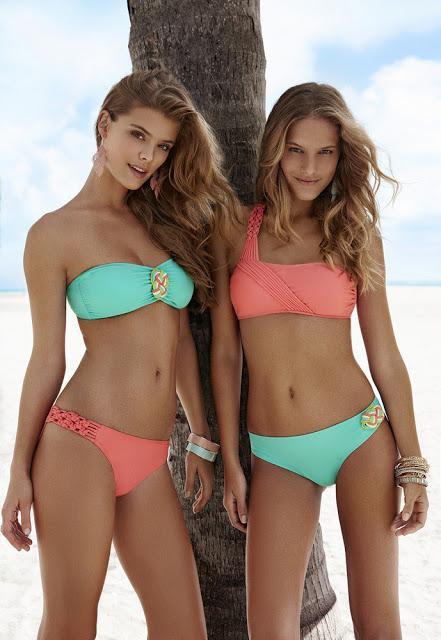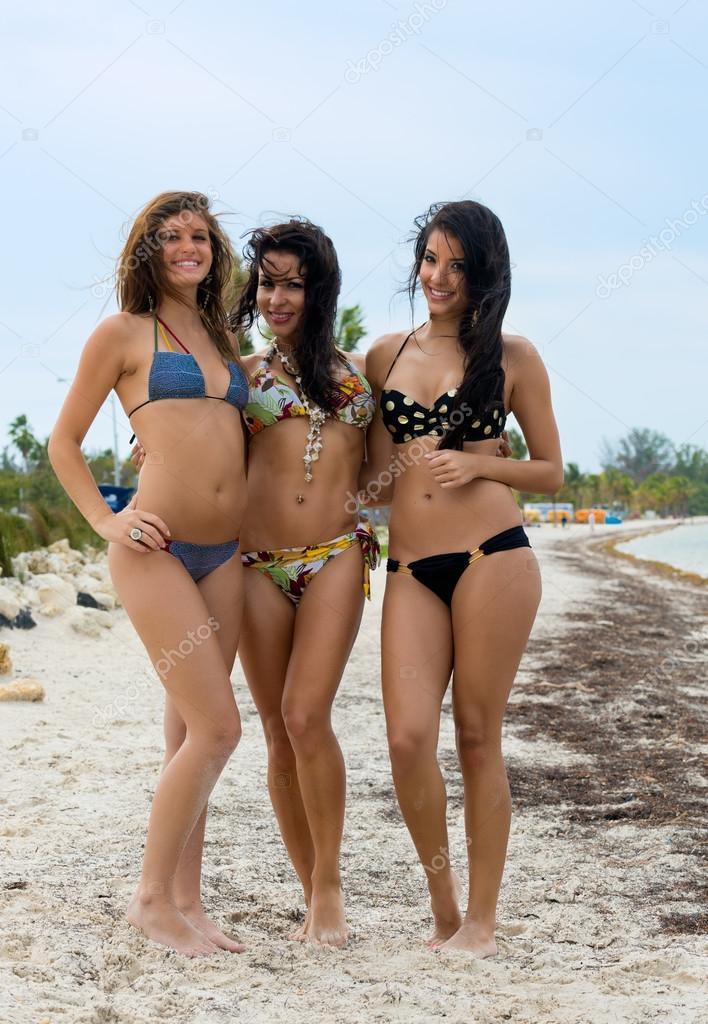The first image is the image on the left, the second image is the image on the right. For the images displayed, is the sentence "There is at least two females in a bikini in the right image." factually correct? Answer yes or no. Yes. The first image is the image on the left, the second image is the image on the right. For the images displayed, is the sentence "An image shows three models in different bikini colors." factually correct? Answer yes or no. Yes. 